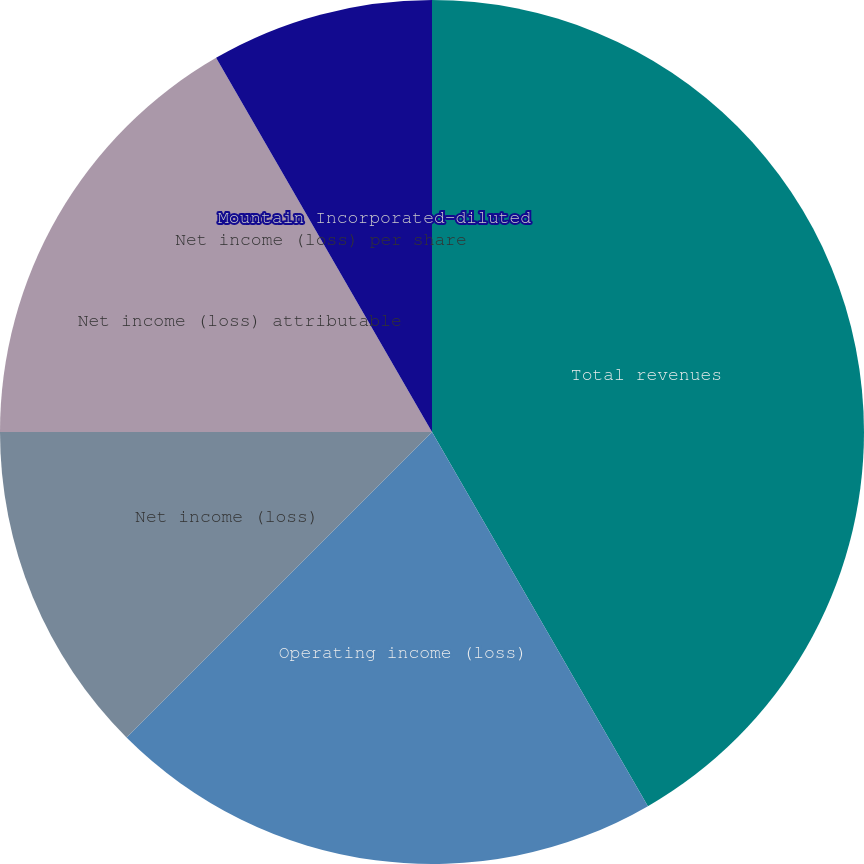<chart> <loc_0><loc_0><loc_500><loc_500><pie_chart><fcel>Total revenues<fcel>Operating income (loss)<fcel>Net income (loss)<fcel>Net income (loss) attributable<fcel>Net income (loss) per share<fcel>Mountain Incorporated-diluted<nl><fcel>41.67%<fcel>20.83%<fcel>12.5%<fcel>16.67%<fcel>0.0%<fcel>8.33%<nl></chart> 